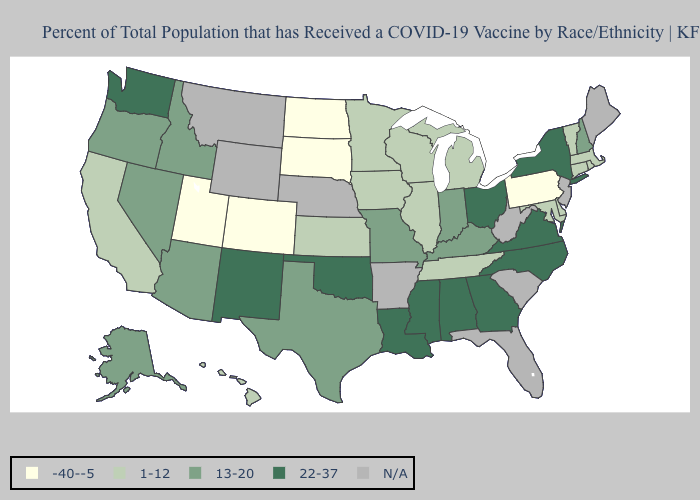What is the value of Kentucky?
Write a very short answer. 13-20. What is the highest value in the USA?
Give a very brief answer. 22-37. Does the map have missing data?
Be succinct. Yes. Does Washington have the highest value in the West?
Concise answer only. Yes. Among the states that border Wisconsin , which have the highest value?
Answer briefly. Illinois, Iowa, Michigan, Minnesota. Which states have the lowest value in the USA?
Short answer required. Colorado, North Dakota, Pennsylvania, South Dakota, Utah. How many symbols are there in the legend?
Short answer required. 5. What is the lowest value in states that border Delaware?
Concise answer only. -40--5. Name the states that have a value in the range -40--5?
Concise answer only. Colorado, North Dakota, Pennsylvania, South Dakota, Utah. What is the highest value in the West ?
Be succinct. 22-37. Name the states that have a value in the range 1-12?
Answer briefly. California, Connecticut, Delaware, Hawaii, Illinois, Iowa, Kansas, Maryland, Massachusetts, Michigan, Minnesota, Rhode Island, Tennessee, Vermont, Wisconsin. Does Nevada have the highest value in the USA?
Quick response, please. No. What is the value of Arizona?
Short answer required. 13-20. What is the value of Utah?
Write a very short answer. -40--5. 